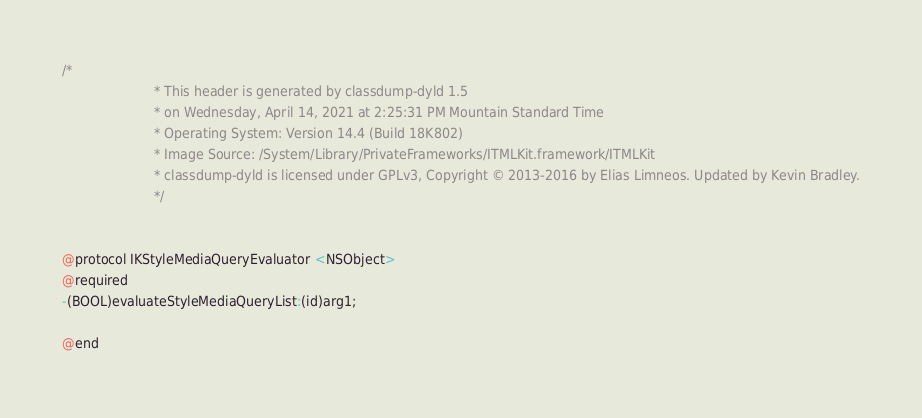<code> <loc_0><loc_0><loc_500><loc_500><_C_>/*
                       * This header is generated by classdump-dyld 1.5
                       * on Wednesday, April 14, 2021 at 2:25:31 PM Mountain Standard Time
                       * Operating System: Version 14.4 (Build 18K802)
                       * Image Source: /System/Library/PrivateFrameworks/ITMLKit.framework/ITMLKit
                       * classdump-dyld is licensed under GPLv3, Copyright © 2013-2016 by Elias Limneos. Updated by Kevin Bradley.
                       */


@protocol IKStyleMediaQueryEvaluator <NSObject>
@required
-(BOOL)evaluateStyleMediaQueryList:(id)arg1;

@end

</code> 